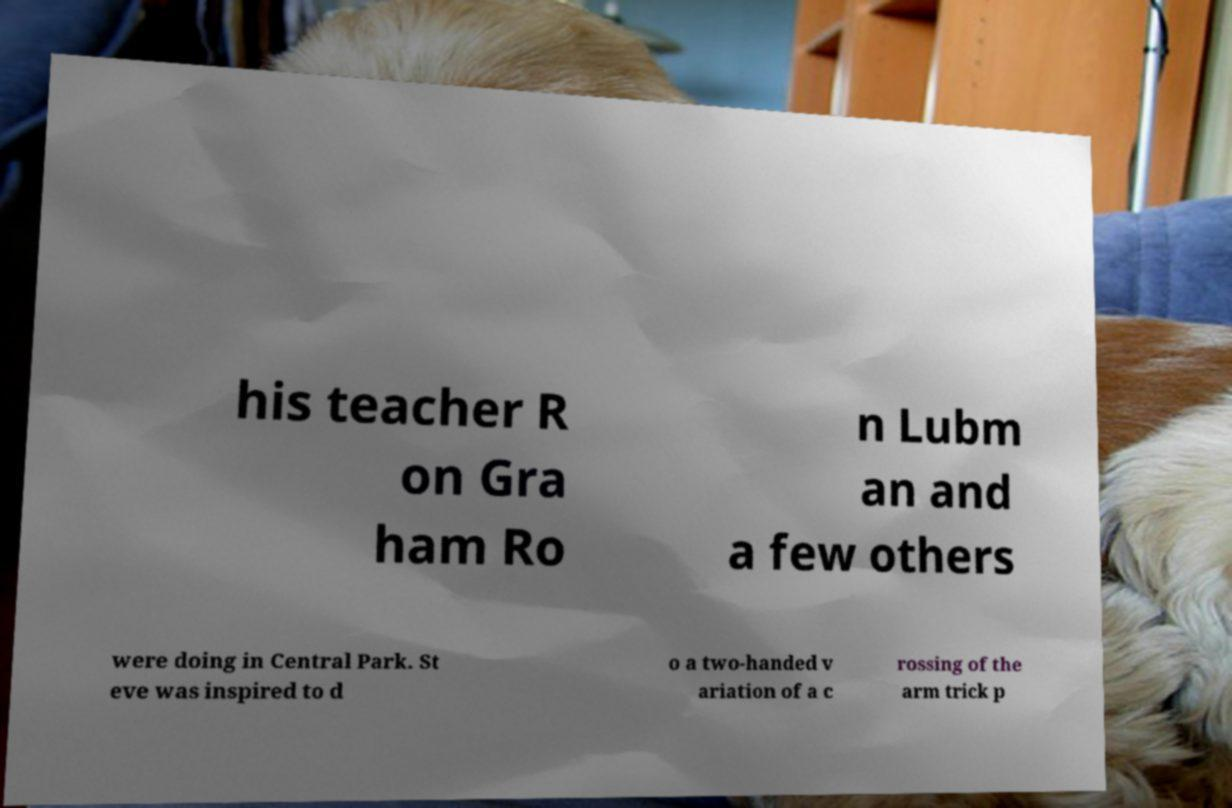Could you extract and type out the text from this image? his teacher R on Gra ham Ro n Lubm an and a few others were doing in Central Park. St eve was inspired to d o a two-handed v ariation of a c rossing of the arm trick p 